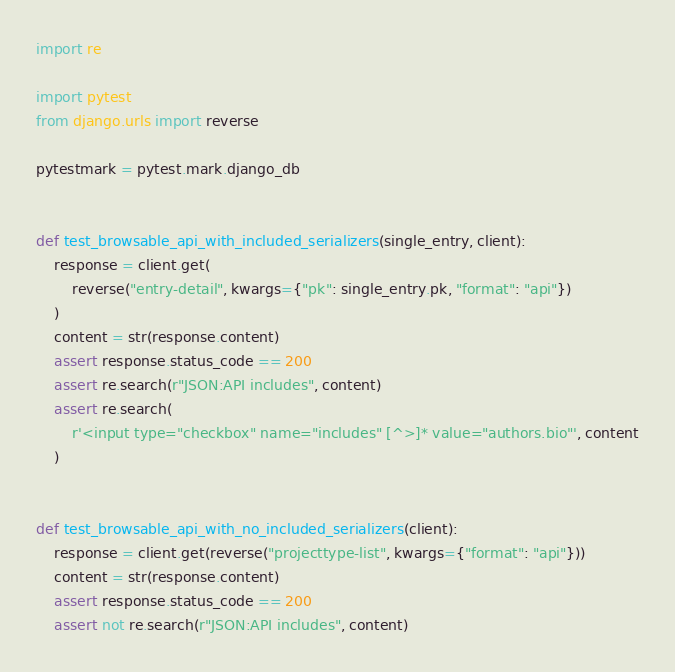Convert code to text. <code><loc_0><loc_0><loc_500><loc_500><_Python_>import re

import pytest
from django.urls import reverse

pytestmark = pytest.mark.django_db


def test_browsable_api_with_included_serializers(single_entry, client):
    response = client.get(
        reverse("entry-detail", kwargs={"pk": single_entry.pk, "format": "api"})
    )
    content = str(response.content)
    assert response.status_code == 200
    assert re.search(r"JSON:API includes", content)
    assert re.search(
        r'<input type="checkbox" name="includes" [^>]* value="authors.bio"', content
    )


def test_browsable_api_with_no_included_serializers(client):
    response = client.get(reverse("projecttype-list", kwargs={"format": "api"}))
    content = str(response.content)
    assert response.status_code == 200
    assert not re.search(r"JSON:API includes", content)
</code> 